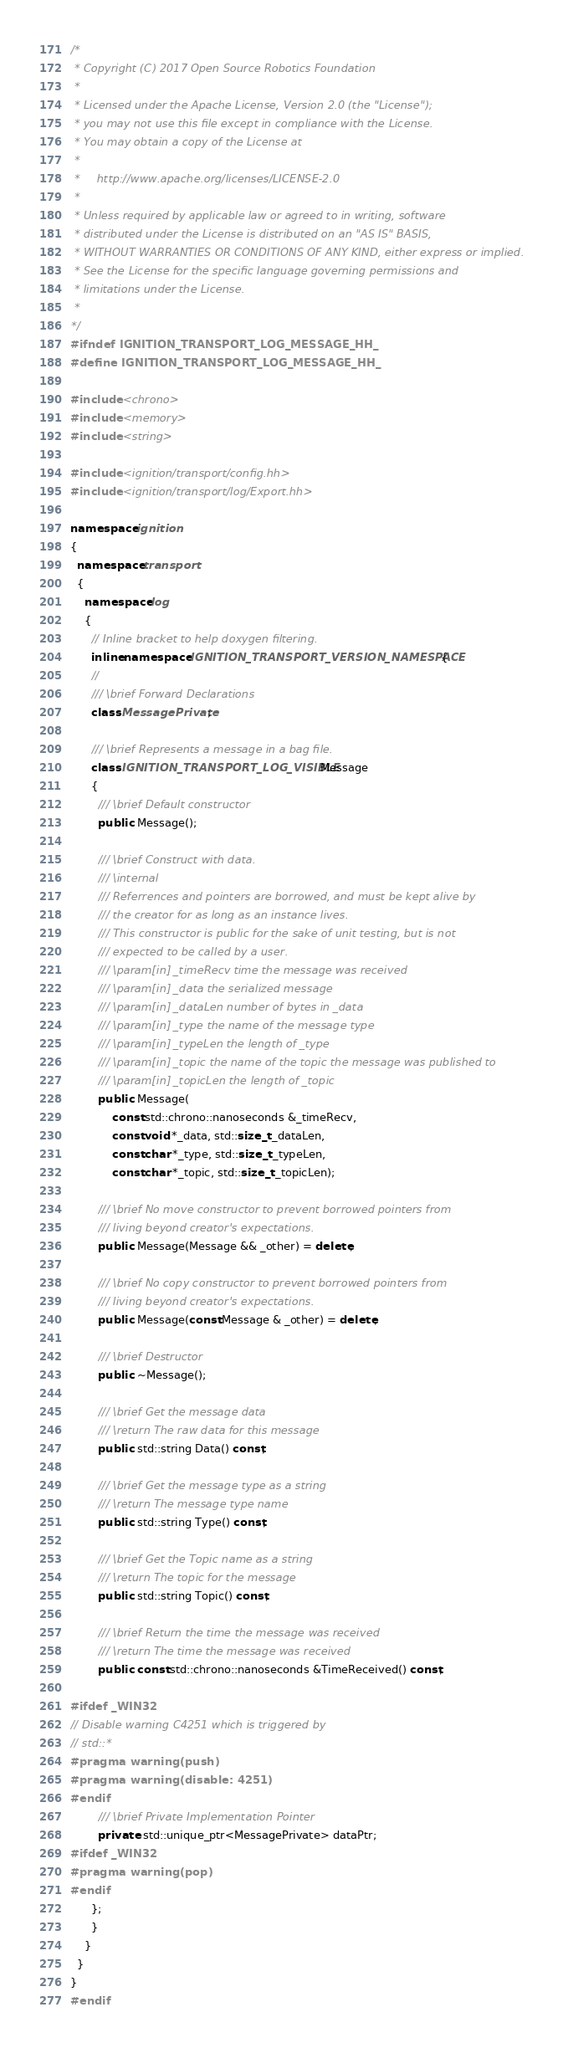Convert code to text. <code><loc_0><loc_0><loc_500><loc_500><_C++_>/*
 * Copyright (C) 2017 Open Source Robotics Foundation
 *
 * Licensed under the Apache License, Version 2.0 (the "License");
 * you may not use this file except in compliance with the License.
 * You may obtain a copy of the License at
 *
 *     http://www.apache.org/licenses/LICENSE-2.0
 *
 * Unless required by applicable law or agreed to in writing, software
 * distributed under the License is distributed on an "AS IS" BASIS,
 * WITHOUT WARRANTIES OR CONDITIONS OF ANY KIND, either express or implied.
 * See the License for the specific language governing permissions and
 * limitations under the License.
 *
*/
#ifndef IGNITION_TRANSPORT_LOG_MESSAGE_HH_
#define IGNITION_TRANSPORT_LOG_MESSAGE_HH_

#include <chrono>
#include <memory>
#include <string>

#include <ignition/transport/config.hh>
#include <ignition/transport/log/Export.hh>

namespace ignition
{
  namespace transport
  {
    namespace log
    {
      // Inline bracket to help doxygen filtering.
      inline namespace IGNITION_TRANSPORT_VERSION_NAMESPACE {
      //
      /// \brief Forward Declarations
      class MessagePrivate;

      /// \brief Represents a message in a bag file.
      class IGNITION_TRANSPORT_LOG_VISIBLE Message
      {
        /// \brief Default constructor
        public: Message();

        /// \brief Construct with data.
        /// \internal
        /// Referrences and pointers are borrowed, and must be kept alive by
        /// the creator for as long as an instance lives.
        /// This constructor is public for the sake of unit testing, but is not
        /// expected to be called by a user.
        /// \param[in] _timeRecv time the message was received
        /// \param[in] _data the serialized message
        /// \param[in] _dataLen number of bytes in _data
        /// \param[in] _type the name of the message type
        /// \param[in] _typeLen the length of _type
        /// \param[in] _topic the name of the topic the message was published to
        /// \param[in] _topicLen the length of _topic
        public: Message(
            const std::chrono::nanoseconds &_timeRecv,
            const void *_data, std::size_t _dataLen,
            const char *_type, std::size_t _typeLen,
            const char *_topic, std::size_t _topicLen);

        /// \brief No move constructor to prevent borrowed pointers from
        /// living beyond creator's expectations.
        public: Message(Message && _other) = delete;

        /// \brief No copy constructor to prevent borrowed pointers from
        /// living beyond creator's expectations.
        public: Message(const Message & _other) = delete;

        /// \brief Destructor
        public: ~Message();

        /// \brief Get the message data
        /// \return The raw data for this message
        public: std::string Data() const;

        /// \brief Get the message type as a string
        /// \return The message type name
        public: std::string Type() const;

        /// \brief Get the Topic name as a string
        /// \return The topic for the message
        public: std::string Topic() const;

        /// \brief Return the time the message was received
        /// \return The time the message was received
        public: const std::chrono::nanoseconds &TimeReceived() const;

#ifdef _WIN32
// Disable warning C4251 which is triggered by
// std::*
#pragma warning(push)
#pragma warning(disable: 4251)
#endif
        /// \brief Private Implementation Pointer
        private: std::unique_ptr<MessagePrivate> dataPtr;
#ifdef _WIN32
#pragma warning(pop)
#endif
      };
      }
    }
  }
}
#endif
</code> 